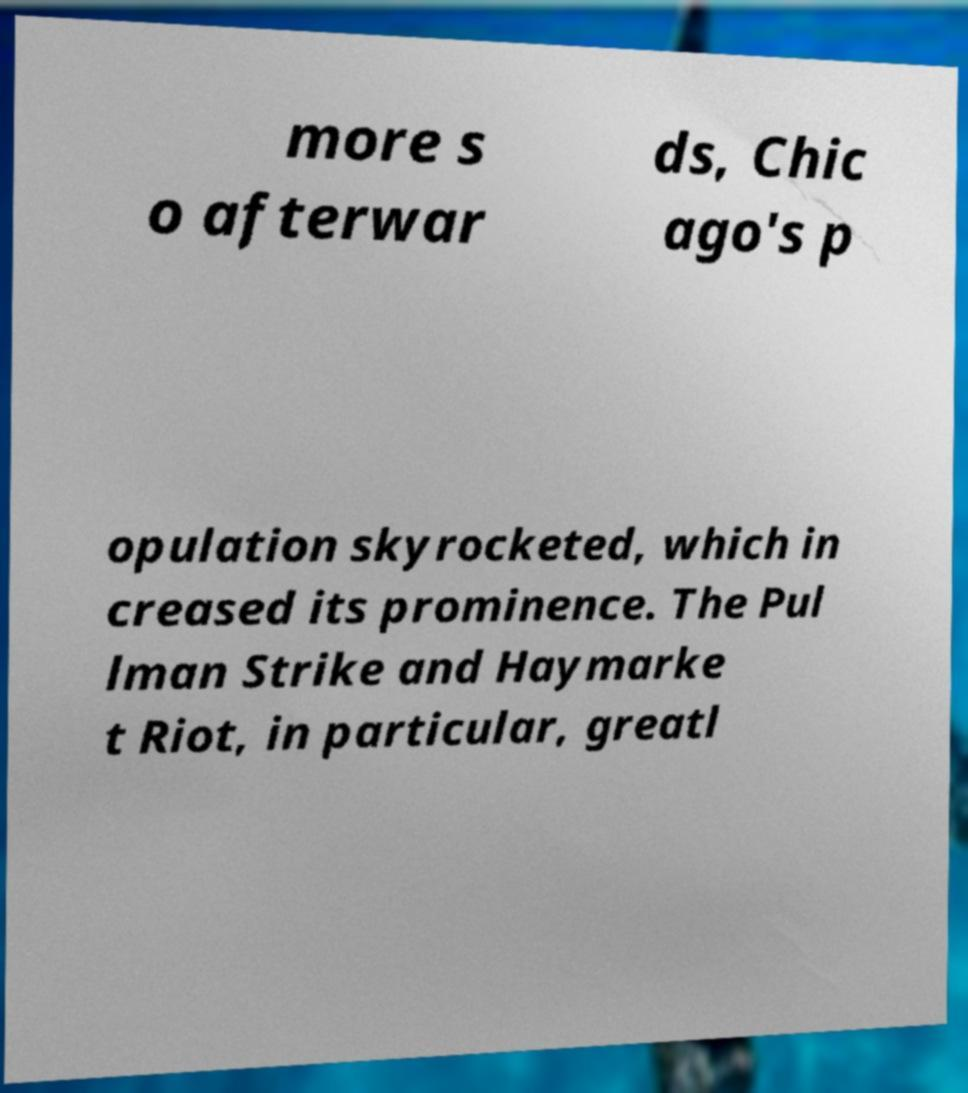Please identify and transcribe the text found in this image. more s o afterwar ds, Chic ago's p opulation skyrocketed, which in creased its prominence. The Pul lman Strike and Haymarke t Riot, in particular, greatl 